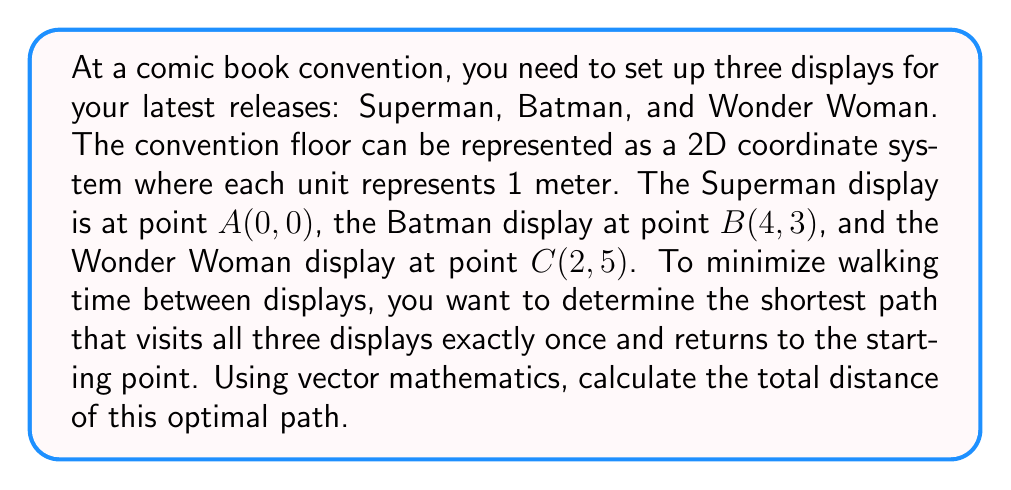Could you help me with this problem? To solve this problem, we'll use vector mathematics to calculate the distances between the displays and determine the shortest path.

1) First, let's define the vectors between the points:
   $$\vec{AB} = (4-0, 3-0) = (4, 3)$$
   $$\vec{BC} = (2-4, 5-3) = (-2, 2)$$
   $$\vec{CA} = (0-2, 0-5) = (-2, -5)$$

2) Calculate the magnitude of each vector to find the distances:
   $$|\vec{AB}| = \sqrt{4^2 + 3^2} = \sqrt{25} = 5$$
   $$|\vec{BC}| = \sqrt{(-2)^2 + 2^2} = \sqrt{8} = 2\sqrt{2}$$
   $$|\vec{CA}| = \sqrt{(-2)^2 + (-5)^2} = \sqrt{29}$$

3) The total distance will be the sum of these magnitudes:
   $$\text{Total Distance} = |\vec{AB}| + |\vec{BC}| + |\vec{CA}|$$

4) Substitute the values:
   $$\text{Total Distance} = 5 + 2\sqrt{2} + \sqrt{29}$$

This path (A → B → C → A) is indeed the shortest because it forms a triangle, and in a triangle, the sum of any two sides is always greater than the third side. Any other path would involve backtracking, which would increase the total distance.
Answer: The shortest path visiting all three displays once and returning to the start is $5 + 2\sqrt{2} + \sqrt{29}$ meters. 